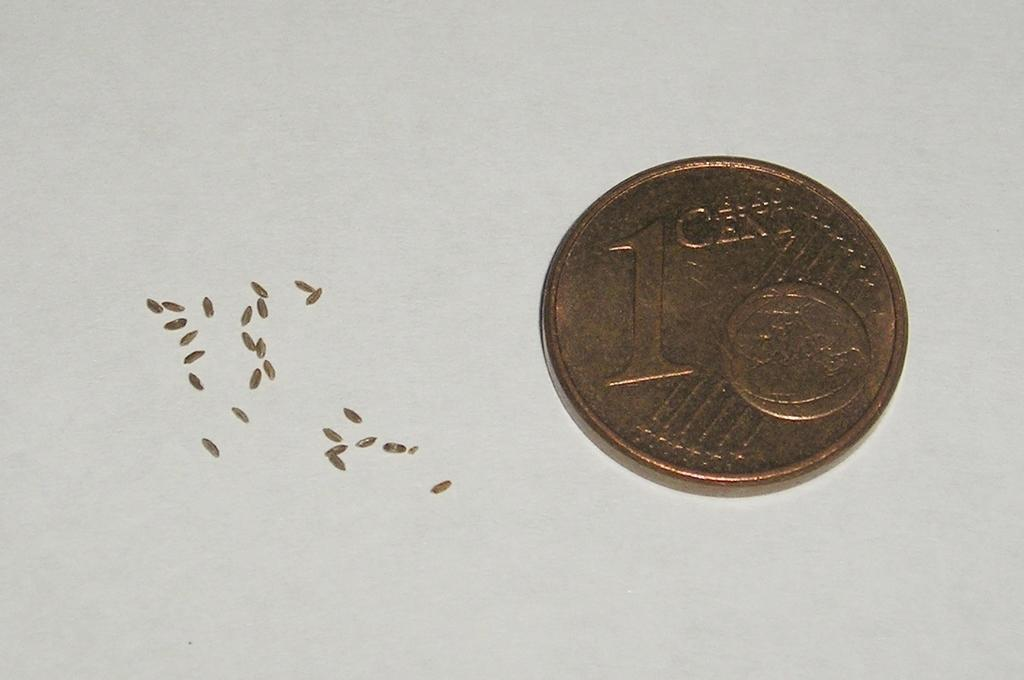<image>
Render a clear and concise summary of the photo. A 1 cent copper coin sits against a white background 